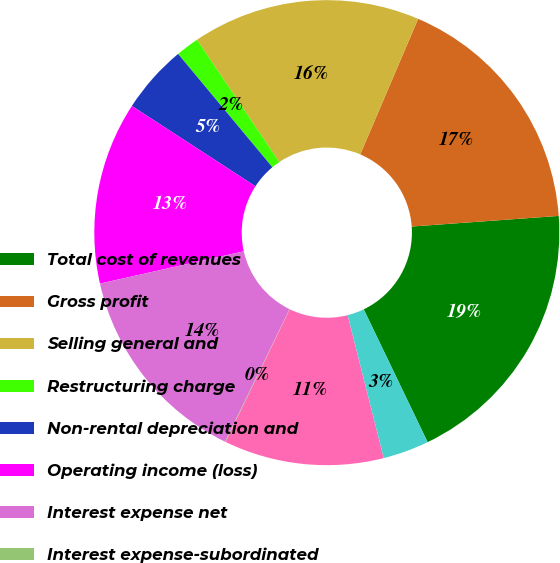Convert chart. <chart><loc_0><loc_0><loc_500><loc_500><pie_chart><fcel>Total cost of revenues<fcel>Gross profit<fcel>Selling general and<fcel>Restructuring charge<fcel>Non-rental depreciation and<fcel>Operating income (loss)<fcel>Interest expense net<fcel>Interest expense-subordinated<fcel>Income (loss) from continuing<fcel>Provision (benefit) for income<nl><fcel>19.01%<fcel>17.43%<fcel>15.85%<fcel>1.62%<fcel>4.78%<fcel>12.69%<fcel>14.27%<fcel>0.04%<fcel>11.11%<fcel>3.2%<nl></chart> 